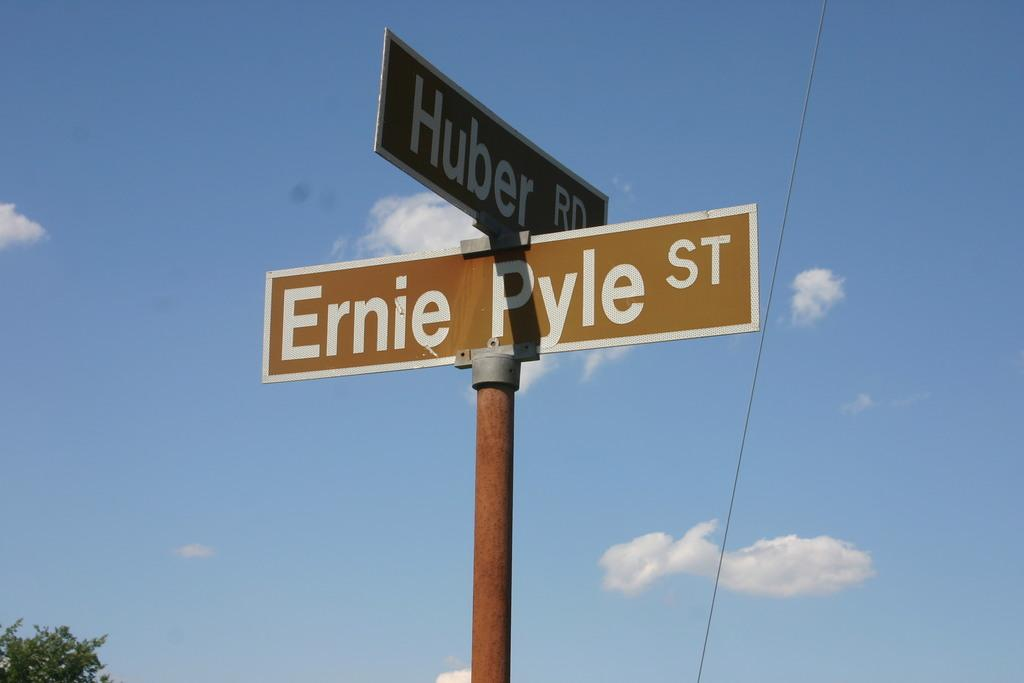<image>
Give a short and clear explanation of the subsequent image. A sign at the intersection of Ernie Pyle St. and Huber Rd. 